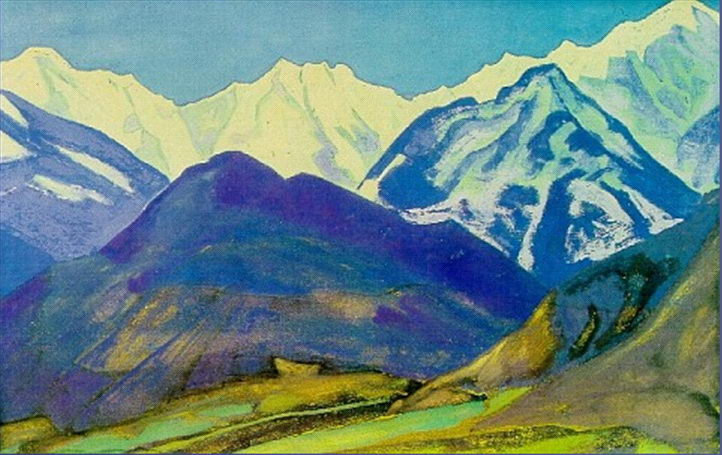If this landscape could tell us a story, what would it be? This majestic landscape might tell the story of ancient earth movements that lifted these mountains skyward, creating a sanctuary of diverse flora and fauna. It could narrate tales of explorers and settlers who once traversed its passages, seeking fortune or solitude. Perhaps it would recount the simple daily life in the valley—children playing by the water, farmers cultivating their land, and families gazing upon the sharegpt4v/same unchanging peaks through generations. This ageless story could weave the timeless interplay of natural splendor and human endeavor, capturing both mundane and extraordinary moments in its eternal beauty. 